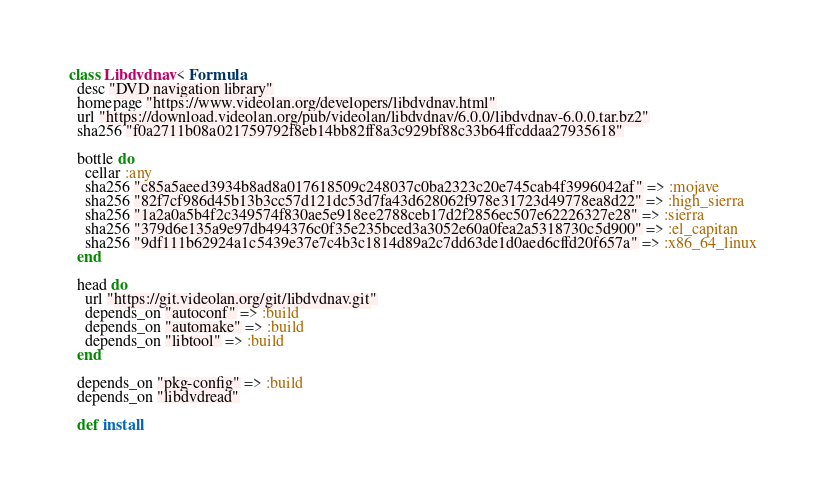<code> <loc_0><loc_0><loc_500><loc_500><_Ruby_>class Libdvdnav < Formula
  desc "DVD navigation library"
  homepage "https://www.videolan.org/developers/libdvdnav.html"
  url "https://download.videolan.org/pub/videolan/libdvdnav/6.0.0/libdvdnav-6.0.0.tar.bz2"
  sha256 "f0a2711b08a021759792f8eb14bb82ff8a3c929bf88c33b64ffcddaa27935618"

  bottle do
    cellar :any
    sha256 "c85a5aeed3934b8ad8a017618509c248037c0ba2323c20e745cab4f3996042af" => :mojave
    sha256 "82f7cf986d45b13b3cc57d121dc53d7fa43d628062f978e31723d49778ea8d22" => :high_sierra
    sha256 "1a2a0a5b4f2c349574f830ae5e918ee2788ceb17d2f2856ec507e62226327e28" => :sierra
    sha256 "379d6e135a9e97db494376c0f35e235bced3a3052e60a0fea2a5318730c5d900" => :el_capitan
    sha256 "9df111b62924a1c5439e37e7c4b3c1814d89a2c7dd63de1d0aed6cffd20f657a" => :x86_64_linux
  end

  head do
    url "https://git.videolan.org/git/libdvdnav.git"
    depends_on "autoconf" => :build
    depends_on "automake" => :build
    depends_on "libtool" => :build
  end

  depends_on "pkg-config" => :build
  depends_on "libdvdread"

  def install</code> 